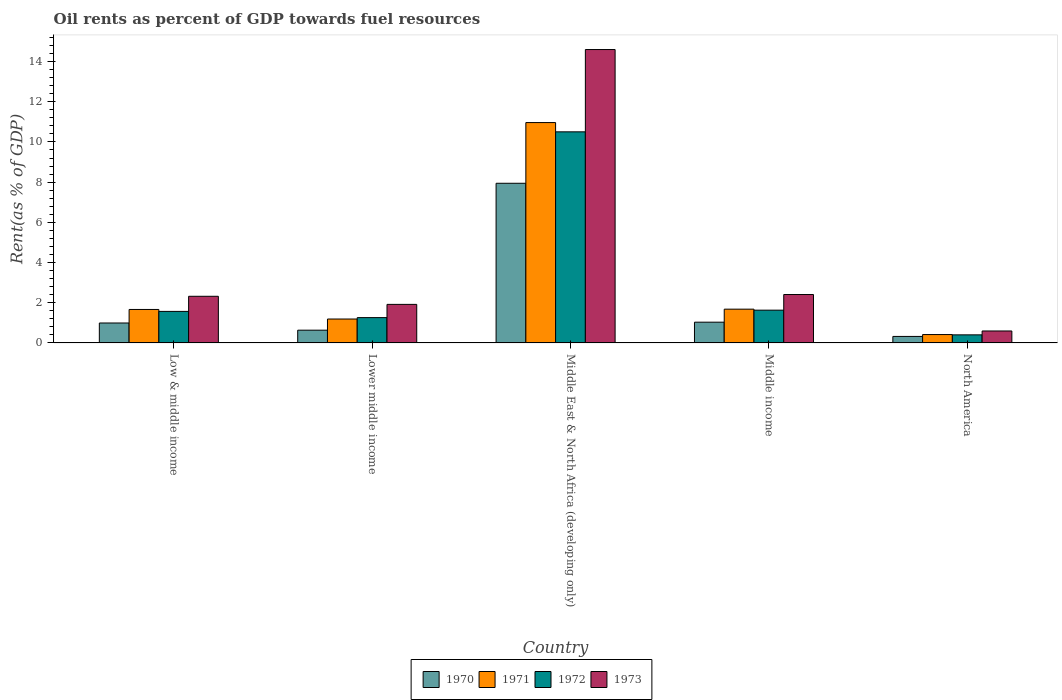Are the number of bars per tick equal to the number of legend labels?
Your answer should be compact. Yes. How many bars are there on the 2nd tick from the left?
Your answer should be very brief. 4. What is the label of the 2nd group of bars from the left?
Provide a short and direct response. Lower middle income. In how many cases, is the number of bars for a given country not equal to the number of legend labels?
Provide a short and direct response. 0. What is the oil rent in 1971 in Middle East & North Africa (developing only)?
Your response must be concise. 10.96. Across all countries, what is the maximum oil rent in 1971?
Give a very brief answer. 10.96. Across all countries, what is the minimum oil rent in 1971?
Keep it short and to the point. 0.42. In which country was the oil rent in 1973 maximum?
Provide a short and direct response. Middle East & North Africa (developing only). What is the total oil rent in 1972 in the graph?
Your response must be concise. 15.36. What is the difference between the oil rent in 1973 in Lower middle income and that in Middle East & North Africa (developing only)?
Offer a terse response. -12.68. What is the difference between the oil rent in 1970 in Lower middle income and the oil rent in 1971 in Low & middle income?
Your answer should be very brief. -1.03. What is the average oil rent in 1970 per country?
Provide a succinct answer. 2.19. What is the difference between the oil rent of/in 1973 and oil rent of/in 1970 in Middle income?
Keep it short and to the point. 1.38. What is the ratio of the oil rent in 1973 in Middle income to that in North America?
Offer a terse response. 4.05. Is the difference between the oil rent in 1973 in Low & middle income and North America greater than the difference between the oil rent in 1970 in Low & middle income and North America?
Your response must be concise. Yes. What is the difference between the highest and the second highest oil rent in 1970?
Provide a short and direct response. -0.04. What is the difference between the highest and the lowest oil rent in 1972?
Provide a short and direct response. 10.1. In how many countries, is the oil rent in 1973 greater than the average oil rent in 1973 taken over all countries?
Provide a short and direct response. 1. Is the sum of the oil rent in 1972 in Low & middle income and Middle income greater than the maximum oil rent in 1973 across all countries?
Offer a terse response. No. Is it the case that in every country, the sum of the oil rent in 1971 and oil rent in 1972 is greater than the sum of oil rent in 1973 and oil rent in 1970?
Provide a succinct answer. No. How many bars are there?
Your answer should be compact. 20. Does the graph contain grids?
Offer a very short reply. No. What is the title of the graph?
Your response must be concise. Oil rents as percent of GDP towards fuel resources. Does "1963" appear as one of the legend labels in the graph?
Make the answer very short. No. What is the label or title of the Y-axis?
Provide a succinct answer. Rent(as % of GDP). What is the Rent(as % of GDP) in 1970 in Low & middle income?
Give a very brief answer. 0.99. What is the Rent(as % of GDP) of 1971 in Low & middle income?
Make the answer very short. 1.67. What is the Rent(as % of GDP) of 1972 in Low & middle income?
Offer a very short reply. 1.57. What is the Rent(as % of GDP) in 1973 in Low & middle income?
Provide a succinct answer. 2.32. What is the Rent(as % of GDP) in 1970 in Lower middle income?
Give a very brief answer. 0.63. What is the Rent(as % of GDP) of 1971 in Lower middle income?
Make the answer very short. 1.19. What is the Rent(as % of GDP) in 1972 in Lower middle income?
Give a very brief answer. 1.26. What is the Rent(as % of GDP) in 1973 in Lower middle income?
Your answer should be very brief. 1.92. What is the Rent(as % of GDP) of 1970 in Middle East & North Africa (developing only)?
Keep it short and to the point. 7.94. What is the Rent(as % of GDP) in 1971 in Middle East & North Africa (developing only)?
Offer a terse response. 10.96. What is the Rent(as % of GDP) of 1972 in Middle East & North Africa (developing only)?
Offer a very short reply. 10.5. What is the Rent(as % of GDP) in 1973 in Middle East & North Africa (developing only)?
Provide a short and direct response. 14.6. What is the Rent(as % of GDP) in 1970 in Middle income?
Your answer should be very brief. 1.03. What is the Rent(as % of GDP) in 1971 in Middle income?
Give a very brief answer. 1.68. What is the Rent(as % of GDP) in 1972 in Middle income?
Give a very brief answer. 1.63. What is the Rent(as % of GDP) of 1973 in Middle income?
Keep it short and to the point. 2.41. What is the Rent(as % of GDP) in 1970 in North America?
Give a very brief answer. 0.32. What is the Rent(as % of GDP) of 1971 in North America?
Your answer should be very brief. 0.42. What is the Rent(as % of GDP) of 1972 in North America?
Ensure brevity in your answer.  0.4. What is the Rent(as % of GDP) of 1973 in North America?
Give a very brief answer. 0.6. Across all countries, what is the maximum Rent(as % of GDP) in 1970?
Your answer should be very brief. 7.94. Across all countries, what is the maximum Rent(as % of GDP) of 1971?
Your answer should be very brief. 10.96. Across all countries, what is the maximum Rent(as % of GDP) of 1972?
Provide a succinct answer. 10.5. Across all countries, what is the maximum Rent(as % of GDP) in 1973?
Offer a terse response. 14.6. Across all countries, what is the minimum Rent(as % of GDP) of 1970?
Offer a very short reply. 0.32. Across all countries, what is the minimum Rent(as % of GDP) in 1971?
Offer a very short reply. 0.42. Across all countries, what is the minimum Rent(as % of GDP) in 1972?
Offer a very short reply. 0.4. Across all countries, what is the minimum Rent(as % of GDP) of 1973?
Give a very brief answer. 0.6. What is the total Rent(as % of GDP) of 1970 in the graph?
Keep it short and to the point. 10.93. What is the total Rent(as % of GDP) of 1971 in the graph?
Your answer should be very brief. 15.92. What is the total Rent(as % of GDP) in 1972 in the graph?
Ensure brevity in your answer.  15.36. What is the total Rent(as % of GDP) in 1973 in the graph?
Your answer should be compact. 21.84. What is the difference between the Rent(as % of GDP) in 1970 in Low & middle income and that in Lower middle income?
Offer a very short reply. 0.36. What is the difference between the Rent(as % of GDP) in 1971 in Low & middle income and that in Lower middle income?
Ensure brevity in your answer.  0.48. What is the difference between the Rent(as % of GDP) in 1972 in Low & middle income and that in Lower middle income?
Your response must be concise. 0.31. What is the difference between the Rent(as % of GDP) in 1973 in Low & middle income and that in Lower middle income?
Give a very brief answer. 0.4. What is the difference between the Rent(as % of GDP) of 1970 in Low & middle income and that in Middle East & North Africa (developing only)?
Offer a very short reply. -6.95. What is the difference between the Rent(as % of GDP) of 1971 in Low & middle income and that in Middle East & North Africa (developing only)?
Offer a very short reply. -9.3. What is the difference between the Rent(as % of GDP) of 1972 in Low & middle income and that in Middle East & North Africa (developing only)?
Offer a very short reply. -8.93. What is the difference between the Rent(as % of GDP) in 1973 in Low & middle income and that in Middle East & North Africa (developing only)?
Make the answer very short. -12.28. What is the difference between the Rent(as % of GDP) of 1970 in Low & middle income and that in Middle income?
Provide a short and direct response. -0.04. What is the difference between the Rent(as % of GDP) in 1971 in Low & middle income and that in Middle income?
Provide a short and direct response. -0.01. What is the difference between the Rent(as % of GDP) of 1972 in Low & middle income and that in Middle income?
Your response must be concise. -0.06. What is the difference between the Rent(as % of GDP) of 1973 in Low & middle income and that in Middle income?
Make the answer very short. -0.09. What is the difference between the Rent(as % of GDP) in 1970 in Low & middle income and that in North America?
Keep it short and to the point. 0.67. What is the difference between the Rent(as % of GDP) in 1971 in Low & middle income and that in North America?
Offer a very short reply. 1.25. What is the difference between the Rent(as % of GDP) in 1972 in Low & middle income and that in North America?
Ensure brevity in your answer.  1.17. What is the difference between the Rent(as % of GDP) in 1973 in Low & middle income and that in North America?
Make the answer very short. 1.73. What is the difference between the Rent(as % of GDP) in 1970 in Lower middle income and that in Middle East & North Africa (developing only)?
Offer a terse response. -7.31. What is the difference between the Rent(as % of GDP) of 1971 in Lower middle income and that in Middle East & North Africa (developing only)?
Make the answer very short. -9.77. What is the difference between the Rent(as % of GDP) of 1972 in Lower middle income and that in Middle East & North Africa (developing only)?
Offer a terse response. -9.24. What is the difference between the Rent(as % of GDP) in 1973 in Lower middle income and that in Middle East & North Africa (developing only)?
Keep it short and to the point. -12.68. What is the difference between the Rent(as % of GDP) in 1970 in Lower middle income and that in Middle income?
Your answer should be compact. -0.4. What is the difference between the Rent(as % of GDP) in 1971 in Lower middle income and that in Middle income?
Give a very brief answer. -0.49. What is the difference between the Rent(as % of GDP) of 1972 in Lower middle income and that in Middle income?
Offer a very short reply. -0.37. What is the difference between the Rent(as % of GDP) in 1973 in Lower middle income and that in Middle income?
Make the answer very short. -0.49. What is the difference between the Rent(as % of GDP) of 1970 in Lower middle income and that in North America?
Your response must be concise. 0.31. What is the difference between the Rent(as % of GDP) of 1971 in Lower middle income and that in North America?
Keep it short and to the point. 0.77. What is the difference between the Rent(as % of GDP) of 1972 in Lower middle income and that in North America?
Provide a short and direct response. 0.86. What is the difference between the Rent(as % of GDP) in 1973 in Lower middle income and that in North America?
Keep it short and to the point. 1.32. What is the difference between the Rent(as % of GDP) of 1970 in Middle East & North Africa (developing only) and that in Middle income?
Provide a succinct answer. 6.91. What is the difference between the Rent(as % of GDP) of 1971 in Middle East & North Africa (developing only) and that in Middle income?
Make the answer very short. 9.28. What is the difference between the Rent(as % of GDP) of 1972 in Middle East & North Africa (developing only) and that in Middle income?
Your answer should be compact. 8.87. What is the difference between the Rent(as % of GDP) of 1973 in Middle East & North Africa (developing only) and that in Middle income?
Provide a succinct answer. 12.19. What is the difference between the Rent(as % of GDP) in 1970 in Middle East & North Africa (developing only) and that in North America?
Give a very brief answer. 7.62. What is the difference between the Rent(as % of GDP) in 1971 in Middle East & North Africa (developing only) and that in North America?
Provide a short and direct response. 10.55. What is the difference between the Rent(as % of GDP) of 1972 in Middle East & North Africa (developing only) and that in North America?
Ensure brevity in your answer.  10.1. What is the difference between the Rent(as % of GDP) of 1973 in Middle East & North Africa (developing only) and that in North America?
Offer a terse response. 14. What is the difference between the Rent(as % of GDP) of 1970 in Middle income and that in North America?
Keep it short and to the point. 0.71. What is the difference between the Rent(as % of GDP) of 1971 in Middle income and that in North America?
Your response must be concise. 1.26. What is the difference between the Rent(as % of GDP) in 1972 in Middle income and that in North America?
Keep it short and to the point. 1.23. What is the difference between the Rent(as % of GDP) in 1973 in Middle income and that in North America?
Give a very brief answer. 1.81. What is the difference between the Rent(as % of GDP) in 1970 in Low & middle income and the Rent(as % of GDP) in 1971 in Lower middle income?
Your response must be concise. -0.2. What is the difference between the Rent(as % of GDP) of 1970 in Low & middle income and the Rent(as % of GDP) of 1972 in Lower middle income?
Give a very brief answer. -0.27. What is the difference between the Rent(as % of GDP) in 1970 in Low & middle income and the Rent(as % of GDP) in 1973 in Lower middle income?
Ensure brevity in your answer.  -0.93. What is the difference between the Rent(as % of GDP) in 1971 in Low & middle income and the Rent(as % of GDP) in 1972 in Lower middle income?
Keep it short and to the point. 0.41. What is the difference between the Rent(as % of GDP) of 1971 in Low & middle income and the Rent(as % of GDP) of 1973 in Lower middle income?
Offer a very short reply. -0.25. What is the difference between the Rent(as % of GDP) in 1972 in Low & middle income and the Rent(as % of GDP) in 1973 in Lower middle income?
Offer a terse response. -0.35. What is the difference between the Rent(as % of GDP) in 1970 in Low & middle income and the Rent(as % of GDP) in 1971 in Middle East & North Africa (developing only)?
Your answer should be compact. -9.97. What is the difference between the Rent(as % of GDP) in 1970 in Low & middle income and the Rent(as % of GDP) in 1972 in Middle East & North Africa (developing only)?
Offer a terse response. -9.51. What is the difference between the Rent(as % of GDP) in 1970 in Low & middle income and the Rent(as % of GDP) in 1973 in Middle East & North Africa (developing only)?
Provide a short and direct response. -13.6. What is the difference between the Rent(as % of GDP) of 1971 in Low & middle income and the Rent(as % of GDP) of 1972 in Middle East & North Africa (developing only)?
Offer a very short reply. -8.84. What is the difference between the Rent(as % of GDP) in 1971 in Low & middle income and the Rent(as % of GDP) in 1973 in Middle East & North Africa (developing only)?
Offer a terse response. -12.93. What is the difference between the Rent(as % of GDP) in 1972 in Low & middle income and the Rent(as % of GDP) in 1973 in Middle East & North Africa (developing only)?
Keep it short and to the point. -13.03. What is the difference between the Rent(as % of GDP) of 1970 in Low & middle income and the Rent(as % of GDP) of 1971 in Middle income?
Ensure brevity in your answer.  -0.69. What is the difference between the Rent(as % of GDP) of 1970 in Low & middle income and the Rent(as % of GDP) of 1972 in Middle income?
Ensure brevity in your answer.  -0.64. What is the difference between the Rent(as % of GDP) of 1970 in Low & middle income and the Rent(as % of GDP) of 1973 in Middle income?
Keep it short and to the point. -1.42. What is the difference between the Rent(as % of GDP) of 1971 in Low & middle income and the Rent(as % of GDP) of 1972 in Middle income?
Make the answer very short. 0.03. What is the difference between the Rent(as % of GDP) of 1971 in Low & middle income and the Rent(as % of GDP) of 1973 in Middle income?
Give a very brief answer. -0.74. What is the difference between the Rent(as % of GDP) of 1972 in Low & middle income and the Rent(as % of GDP) of 1973 in Middle income?
Give a very brief answer. -0.84. What is the difference between the Rent(as % of GDP) in 1970 in Low & middle income and the Rent(as % of GDP) in 1971 in North America?
Give a very brief answer. 0.57. What is the difference between the Rent(as % of GDP) in 1970 in Low & middle income and the Rent(as % of GDP) in 1972 in North America?
Give a very brief answer. 0.59. What is the difference between the Rent(as % of GDP) in 1970 in Low & middle income and the Rent(as % of GDP) in 1973 in North America?
Your response must be concise. 0.4. What is the difference between the Rent(as % of GDP) in 1971 in Low & middle income and the Rent(as % of GDP) in 1972 in North America?
Make the answer very short. 1.26. What is the difference between the Rent(as % of GDP) in 1971 in Low & middle income and the Rent(as % of GDP) in 1973 in North America?
Keep it short and to the point. 1.07. What is the difference between the Rent(as % of GDP) in 1972 in Low & middle income and the Rent(as % of GDP) in 1973 in North America?
Give a very brief answer. 0.97. What is the difference between the Rent(as % of GDP) of 1970 in Lower middle income and the Rent(as % of GDP) of 1971 in Middle East & North Africa (developing only)?
Offer a terse response. -10.33. What is the difference between the Rent(as % of GDP) of 1970 in Lower middle income and the Rent(as % of GDP) of 1972 in Middle East & North Africa (developing only)?
Your response must be concise. -9.87. What is the difference between the Rent(as % of GDP) of 1970 in Lower middle income and the Rent(as % of GDP) of 1973 in Middle East & North Africa (developing only)?
Make the answer very short. -13.96. What is the difference between the Rent(as % of GDP) of 1971 in Lower middle income and the Rent(as % of GDP) of 1972 in Middle East & North Africa (developing only)?
Offer a very short reply. -9.31. What is the difference between the Rent(as % of GDP) in 1971 in Lower middle income and the Rent(as % of GDP) in 1973 in Middle East & North Africa (developing only)?
Make the answer very short. -13.41. What is the difference between the Rent(as % of GDP) in 1972 in Lower middle income and the Rent(as % of GDP) in 1973 in Middle East & North Africa (developing only)?
Keep it short and to the point. -13.34. What is the difference between the Rent(as % of GDP) in 1970 in Lower middle income and the Rent(as % of GDP) in 1971 in Middle income?
Provide a succinct answer. -1.05. What is the difference between the Rent(as % of GDP) in 1970 in Lower middle income and the Rent(as % of GDP) in 1972 in Middle income?
Offer a terse response. -1. What is the difference between the Rent(as % of GDP) of 1970 in Lower middle income and the Rent(as % of GDP) of 1973 in Middle income?
Offer a very short reply. -1.77. What is the difference between the Rent(as % of GDP) of 1971 in Lower middle income and the Rent(as % of GDP) of 1972 in Middle income?
Your answer should be very brief. -0.44. What is the difference between the Rent(as % of GDP) of 1971 in Lower middle income and the Rent(as % of GDP) of 1973 in Middle income?
Offer a very short reply. -1.22. What is the difference between the Rent(as % of GDP) in 1972 in Lower middle income and the Rent(as % of GDP) in 1973 in Middle income?
Ensure brevity in your answer.  -1.15. What is the difference between the Rent(as % of GDP) of 1970 in Lower middle income and the Rent(as % of GDP) of 1971 in North America?
Give a very brief answer. 0.22. What is the difference between the Rent(as % of GDP) of 1970 in Lower middle income and the Rent(as % of GDP) of 1972 in North America?
Provide a succinct answer. 0.23. What is the difference between the Rent(as % of GDP) of 1970 in Lower middle income and the Rent(as % of GDP) of 1973 in North America?
Offer a very short reply. 0.04. What is the difference between the Rent(as % of GDP) in 1971 in Lower middle income and the Rent(as % of GDP) in 1972 in North America?
Your answer should be compact. 0.79. What is the difference between the Rent(as % of GDP) in 1971 in Lower middle income and the Rent(as % of GDP) in 1973 in North America?
Offer a terse response. 0.6. What is the difference between the Rent(as % of GDP) of 1972 in Lower middle income and the Rent(as % of GDP) of 1973 in North America?
Offer a very short reply. 0.66. What is the difference between the Rent(as % of GDP) of 1970 in Middle East & North Africa (developing only) and the Rent(as % of GDP) of 1971 in Middle income?
Make the answer very short. 6.26. What is the difference between the Rent(as % of GDP) in 1970 in Middle East & North Africa (developing only) and the Rent(as % of GDP) in 1972 in Middle income?
Offer a terse response. 6.31. What is the difference between the Rent(as % of GDP) of 1970 in Middle East & North Africa (developing only) and the Rent(as % of GDP) of 1973 in Middle income?
Offer a terse response. 5.53. What is the difference between the Rent(as % of GDP) of 1971 in Middle East & North Africa (developing only) and the Rent(as % of GDP) of 1972 in Middle income?
Offer a very short reply. 9.33. What is the difference between the Rent(as % of GDP) in 1971 in Middle East & North Africa (developing only) and the Rent(as % of GDP) in 1973 in Middle income?
Keep it short and to the point. 8.55. What is the difference between the Rent(as % of GDP) of 1972 in Middle East & North Africa (developing only) and the Rent(as % of GDP) of 1973 in Middle income?
Provide a short and direct response. 8.09. What is the difference between the Rent(as % of GDP) of 1970 in Middle East & North Africa (developing only) and the Rent(as % of GDP) of 1971 in North America?
Offer a terse response. 7.53. What is the difference between the Rent(as % of GDP) of 1970 in Middle East & North Africa (developing only) and the Rent(as % of GDP) of 1972 in North America?
Keep it short and to the point. 7.54. What is the difference between the Rent(as % of GDP) in 1970 in Middle East & North Africa (developing only) and the Rent(as % of GDP) in 1973 in North America?
Give a very brief answer. 7.35. What is the difference between the Rent(as % of GDP) of 1971 in Middle East & North Africa (developing only) and the Rent(as % of GDP) of 1972 in North America?
Ensure brevity in your answer.  10.56. What is the difference between the Rent(as % of GDP) in 1971 in Middle East & North Africa (developing only) and the Rent(as % of GDP) in 1973 in North America?
Ensure brevity in your answer.  10.37. What is the difference between the Rent(as % of GDP) in 1972 in Middle East & North Africa (developing only) and the Rent(as % of GDP) in 1973 in North America?
Provide a short and direct response. 9.91. What is the difference between the Rent(as % of GDP) in 1970 in Middle income and the Rent(as % of GDP) in 1971 in North America?
Offer a terse response. 0.61. What is the difference between the Rent(as % of GDP) in 1970 in Middle income and the Rent(as % of GDP) in 1972 in North America?
Offer a terse response. 0.63. What is the difference between the Rent(as % of GDP) in 1970 in Middle income and the Rent(as % of GDP) in 1973 in North America?
Give a very brief answer. 0.44. What is the difference between the Rent(as % of GDP) of 1971 in Middle income and the Rent(as % of GDP) of 1972 in North America?
Provide a short and direct response. 1.28. What is the difference between the Rent(as % of GDP) in 1971 in Middle income and the Rent(as % of GDP) in 1973 in North America?
Provide a short and direct response. 1.09. What is the difference between the Rent(as % of GDP) of 1972 in Middle income and the Rent(as % of GDP) of 1973 in North America?
Your response must be concise. 1.04. What is the average Rent(as % of GDP) in 1970 per country?
Your answer should be compact. 2.19. What is the average Rent(as % of GDP) of 1971 per country?
Your answer should be very brief. 3.18. What is the average Rent(as % of GDP) of 1972 per country?
Keep it short and to the point. 3.07. What is the average Rent(as % of GDP) of 1973 per country?
Offer a very short reply. 4.37. What is the difference between the Rent(as % of GDP) in 1970 and Rent(as % of GDP) in 1971 in Low & middle income?
Make the answer very short. -0.67. What is the difference between the Rent(as % of GDP) in 1970 and Rent(as % of GDP) in 1972 in Low & middle income?
Keep it short and to the point. -0.58. What is the difference between the Rent(as % of GDP) in 1970 and Rent(as % of GDP) in 1973 in Low & middle income?
Make the answer very short. -1.33. What is the difference between the Rent(as % of GDP) of 1971 and Rent(as % of GDP) of 1972 in Low & middle income?
Offer a terse response. 0.1. What is the difference between the Rent(as % of GDP) in 1971 and Rent(as % of GDP) in 1973 in Low & middle income?
Ensure brevity in your answer.  -0.66. What is the difference between the Rent(as % of GDP) in 1972 and Rent(as % of GDP) in 1973 in Low & middle income?
Provide a succinct answer. -0.75. What is the difference between the Rent(as % of GDP) in 1970 and Rent(as % of GDP) in 1971 in Lower middle income?
Provide a succinct answer. -0.56. What is the difference between the Rent(as % of GDP) of 1970 and Rent(as % of GDP) of 1972 in Lower middle income?
Your answer should be very brief. -0.62. What is the difference between the Rent(as % of GDP) in 1970 and Rent(as % of GDP) in 1973 in Lower middle income?
Offer a terse response. -1.28. What is the difference between the Rent(as % of GDP) in 1971 and Rent(as % of GDP) in 1972 in Lower middle income?
Your answer should be very brief. -0.07. What is the difference between the Rent(as % of GDP) of 1971 and Rent(as % of GDP) of 1973 in Lower middle income?
Provide a short and direct response. -0.73. What is the difference between the Rent(as % of GDP) in 1972 and Rent(as % of GDP) in 1973 in Lower middle income?
Offer a terse response. -0.66. What is the difference between the Rent(as % of GDP) of 1970 and Rent(as % of GDP) of 1971 in Middle East & North Africa (developing only)?
Make the answer very short. -3.02. What is the difference between the Rent(as % of GDP) of 1970 and Rent(as % of GDP) of 1972 in Middle East & North Africa (developing only)?
Provide a short and direct response. -2.56. What is the difference between the Rent(as % of GDP) of 1970 and Rent(as % of GDP) of 1973 in Middle East & North Africa (developing only)?
Provide a short and direct response. -6.65. What is the difference between the Rent(as % of GDP) in 1971 and Rent(as % of GDP) in 1972 in Middle East & North Africa (developing only)?
Your answer should be very brief. 0.46. What is the difference between the Rent(as % of GDP) of 1971 and Rent(as % of GDP) of 1973 in Middle East & North Africa (developing only)?
Make the answer very short. -3.63. What is the difference between the Rent(as % of GDP) of 1972 and Rent(as % of GDP) of 1973 in Middle East & North Africa (developing only)?
Offer a very short reply. -4.09. What is the difference between the Rent(as % of GDP) in 1970 and Rent(as % of GDP) in 1971 in Middle income?
Offer a terse response. -0.65. What is the difference between the Rent(as % of GDP) in 1970 and Rent(as % of GDP) in 1972 in Middle income?
Your answer should be very brief. -0.6. What is the difference between the Rent(as % of GDP) of 1970 and Rent(as % of GDP) of 1973 in Middle income?
Ensure brevity in your answer.  -1.38. What is the difference between the Rent(as % of GDP) of 1971 and Rent(as % of GDP) of 1972 in Middle income?
Offer a terse response. 0.05. What is the difference between the Rent(as % of GDP) in 1971 and Rent(as % of GDP) in 1973 in Middle income?
Offer a very short reply. -0.73. What is the difference between the Rent(as % of GDP) of 1972 and Rent(as % of GDP) of 1973 in Middle income?
Keep it short and to the point. -0.78. What is the difference between the Rent(as % of GDP) of 1970 and Rent(as % of GDP) of 1971 in North America?
Provide a short and direct response. -0.09. What is the difference between the Rent(as % of GDP) of 1970 and Rent(as % of GDP) of 1972 in North America?
Ensure brevity in your answer.  -0.08. What is the difference between the Rent(as % of GDP) of 1970 and Rent(as % of GDP) of 1973 in North America?
Provide a succinct answer. -0.27. What is the difference between the Rent(as % of GDP) in 1971 and Rent(as % of GDP) in 1972 in North America?
Make the answer very short. 0.02. What is the difference between the Rent(as % of GDP) in 1971 and Rent(as % of GDP) in 1973 in North America?
Make the answer very short. -0.18. What is the difference between the Rent(as % of GDP) in 1972 and Rent(as % of GDP) in 1973 in North America?
Offer a very short reply. -0.19. What is the ratio of the Rent(as % of GDP) of 1970 in Low & middle income to that in Lower middle income?
Offer a very short reply. 1.56. What is the ratio of the Rent(as % of GDP) in 1971 in Low & middle income to that in Lower middle income?
Give a very brief answer. 1.4. What is the ratio of the Rent(as % of GDP) in 1972 in Low & middle income to that in Lower middle income?
Offer a terse response. 1.25. What is the ratio of the Rent(as % of GDP) of 1973 in Low & middle income to that in Lower middle income?
Offer a terse response. 1.21. What is the ratio of the Rent(as % of GDP) in 1970 in Low & middle income to that in Middle East & North Africa (developing only)?
Offer a very short reply. 0.12. What is the ratio of the Rent(as % of GDP) of 1971 in Low & middle income to that in Middle East & North Africa (developing only)?
Provide a succinct answer. 0.15. What is the ratio of the Rent(as % of GDP) in 1972 in Low & middle income to that in Middle East & North Africa (developing only)?
Ensure brevity in your answer.  0.15. What is the ratio of the Rent(as % of GDP) in 1973 in Low & middle income to that in Middle East & North Africa (developing only)?
Your answer should be compact. 0.16. What is the ratio of the Rent(as % of GDP) of 1970 in Low & middle income to that in Middle income?
Keep it short and to the point. 0.96. What is the ratio of the Rent(as % of GDP) of 1971 in Low & middle income to that in Middle income?
Your response must be concise. 0.99. What is the ratio of the Rent(as % of GDP) of 1972 in Low & middle income to that in Middle income?
Offer a very short reply. 0.96. What is the ratio of the Rent(as % of GDP) in 1973 in Low & middle income to that in Middle income?
Your answer should be very brief. 0.96. What is the ratio of the Rent(as % of GDP) of 1970 in Low & middle income to that in North America?
Give a very brief answer. 3.07. What is the ratio of the Rent(as % of GDP) of 1971 in Low & middle income to that in North America?
Offer a very short reply. 3.99. What is the ratio of the Rent(as % of GDP) of 1972 in Low & middle income to that in North America?
Ensure brevity in your answer.  3.9. What is the ratio of the Rent(as % of GDP) in 1973 in Low & middle income to that in North America?
Your response must be concise. 3.9. What is the ratio of the Rent(as % of GDP) in 1970 in Lower middle income to that in Middle East & North Africa (developing only)?
Provide a succinct answer. 0.08. What is the ratio of the Rent(as % of GDP) of 1971 in Lower middle income to that in Middle East & North Africa (developing only)?
Provide a succinct answer. 0.11. What is the ratio of the Rent(as % of GDP) of 1972 in Lower middle income to that in Middle East & North Africa (developing only)?
Give a very brief answer. 0.12. What is the ratio of the Rent(as % of GDP) of 1973 in Lower middle income to that in Middle East & North Africa (developing only)?
Your answer should be very brief. 0.13. What is the ratio of the Rent(as % of GDP) of 1970 in Lower middle income to that in Middle income?
Your answer should be very brief. 0.61. What is the ratio of the Rent(as % of GDP) in 1971 in Lower middle income to that in Middle income?
Keep it short and to the point. 0.71. What is the ratio of the Rent(as % of GDP) in 1972 in Lower middle income to that in Middle income?
Your response must be concise. 0.77. What is the ratio of the Rent(as % of GDP) in 1973 in Lower middle income to that in Middle income?
Offer a terse response. 0.8. What is the ratio of the Rent(as % of GDP) of 1970 in Lower middle income to that in North America?
Your response must be concise. 1.96. What is the ratio of the Rent(as % of GDP) of 1971 in Lower middle income to that in North America?
Your response must be concise. 2.85. What is the ratio of the Rent(as % of GDP) of 1972 in Lower middle income to that in North America?
Give a very brief answer. 3.13. What is the ratio of the Rent(as % of GDP) in 1973 in Lower middle income to that in North America?
Your answer should be compact. 3.22. What is the ratio of the Rent(as % of GDP) of 1970 in Middle East & North Africa (developing only) to that in Middle income?
Your response must be concise. 7.69. What is the ratio of the Rent(as % of GDP) in 1971 in Middle East & North Africa (developing only) to that in Middle income?
Provide a short and direct response. 6.52. What is the ratio of the Rent(as % of GDP) in 1972 in Middle East & North Africa (developing only) to that in Middle income?
Your answer should be compact. 6.44. What is the ratio of the Rent(as % of GDP) in 1973 in Middle East & North Africa (developing only) to that in Middle income?
Ensure brevity in your answer.  6.06. What is the ratio of the Rent(as % of GDP) in 1970 in Middle East & North Africa (developing only) to that in North America?
Your answer should be very brief. 24.54. What is the ratio of the Rent(as % of GDP) of 1971 in Middle East & North Africa (developing only) to that in North America?
Offer a terse response. 26.26. What is the ratio of the Rent(as % of GDP) in 1972 in Middle East & North Africa (developing only) to that in North America?
Offer a very short reply. 26.11. What is the ratio of the Rent(as % of GDP) in 1973 in Middle East & North Africa (developing only) to that in North America?
Your response must be concise. 24.53. What is the ratio of the Rent(as % of GDP) in 1970 in Middle income to that in North America?
Your response must be concise. 3.19. What is the ratio of the Rent(as % of GDP) in 1971 in Middle income to that in North America?
Provide a succinct answer. 4.03. What is the ratio of the Rent(as % of GDP) in 1972 in Middle income to that in North America?
Offer a terse response. 4.05. What is the ratio of the Rent(as % of GDP) of 1973 in Middle income to that in North America?
Offer a terse response. 4.05. What is the difference between the highest and the second highest Rent(as % of GDP) in 1970?
Offer a terse response. 6.91. What is the difference between the highest and the second highest Rent(as % of GDP) in 1971?
Provide a succinct answer. 9.28. What is the difference between the highest and the second highest Rent(as % of GDP) of 1972?
Provide a succinct answer. 8.87. What is the difference between the highest and the second highest Rent(as % of GDP) of 1973?
Keep it short and to the point. 12.19. What is the difference between the highest and the lowest Rent(as % of GDP) of 1970?
Provide a short and direct response. 7.62. What is the difference between the highest and the lowest Rent(as % of GDP) in 1971?
Ensure brevity in your answer.  10.55. What is the difference between the highest and the lowest Rent(as % of GDP) in 1972?
Provide a succinct answer. 10.1. What is the difference between the highest and the lowest Rent(as % of GDP) of 1973?
Give a very brief answer. 14. 